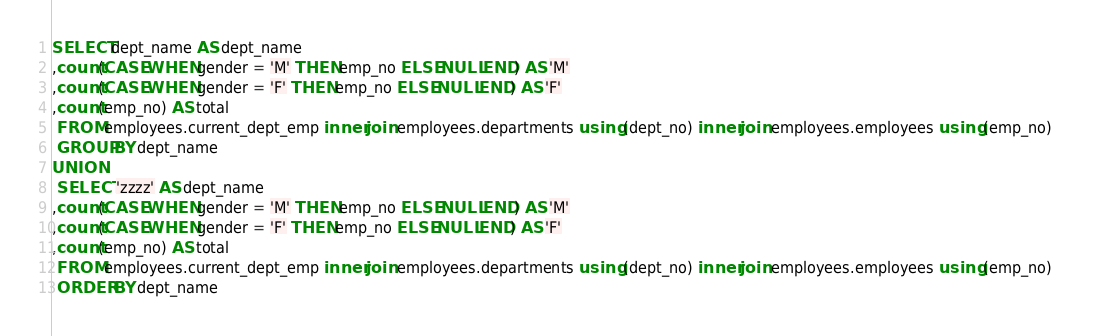Convert code to text. <code><loc_0><loc_0><loc_500><loc_500><_SQL_>SELECT dept_name AS dept_name 
,count(CASE WHEN gender = 'M' THEN emp_no ELSE NULL END) AS 'M' 
,count(CASE WHEN gender = 'F' THEN emp_no ELSE NULL END) AS 'F' 
,count(emp_no) AS total
 FROM employees.current_dept_emp inner join employees.departments using (dept_no) inner join employees.employees using (emp_no) 
 GROUP BY dept_name
UNION
 SELECT 'zzzz' AS dept_name
,count(CASE WHEN gender = 'M' THEN emp_no ELSE NULL END) AS 'M' 
,count(CASE WHEN gender = 'F' THEN emp_no ELSE NULL END) AS 'F' 
,count(emp_no) AS total
 FROM employees.current_dept_emp inner join employees.departments using (dept_no) inner join employees.employees using (emp_no) 
 ORDER BY dept_name

</code> 